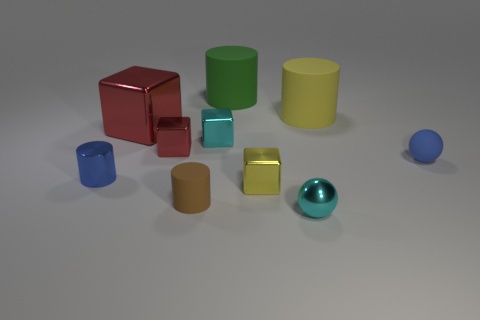There is a green object that is made of the same material as the brown object; what is its size?
Your answer should be compact. Large. Is the number of large yellow matte objects greater than the number of rubber cubes?
Provide a succinct answer. Yes. There is a cyan cube that is the same size as the yellow shiny thing; what is it made of?
Provide a short and direct response. Metal. There is a ball behind the brown rubber thing; is its size the same as the tiny red metallic object?
Your answer should be very brief. Yes. How many balls are either red things or yellow metal objects?
Offer a very short reply. 0. There is a yellow thing on the right side of the small yellow shiny block; what is its material?
Provide a short and direct response. Rubber. Are there fewer green cylinders than big cylinders?
Offer a terse response. Yes. How big is the metal object that is in front of the tiny metallic cylinder and behind the tiny cyan sphere?
Offer a terse response. Small. There is a cyan thing that is behind the rubber thing that is to the left of the small cyan metal thing that is behind the metal cylinder; how big is it?
Your response must be concise. Small. What number of other things are there of the same color as the small rubber sphere?
Give a very brief answer. 1. 